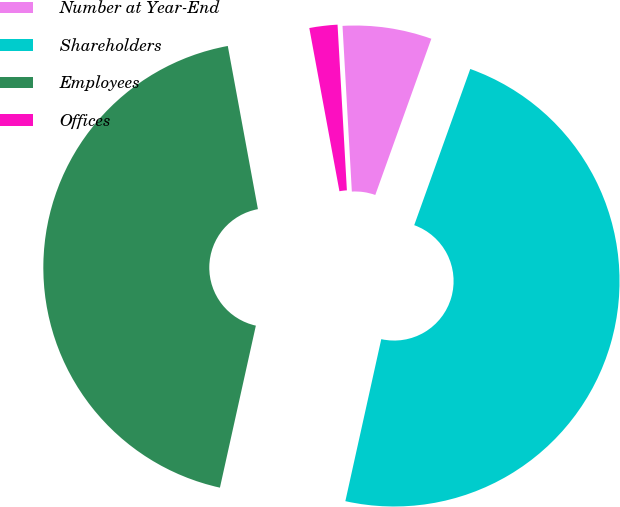<chart> <loc_0><loc_0><loc_500><loc_500><pie_chart><fcel>Number at Year-End<fcel>Shareholders<fcel>Employees<fcel>Offices<nl><fcel>6.38%<fcel>47.99%<fcel>43.62%<fcel>2.01%<nl></chart> 